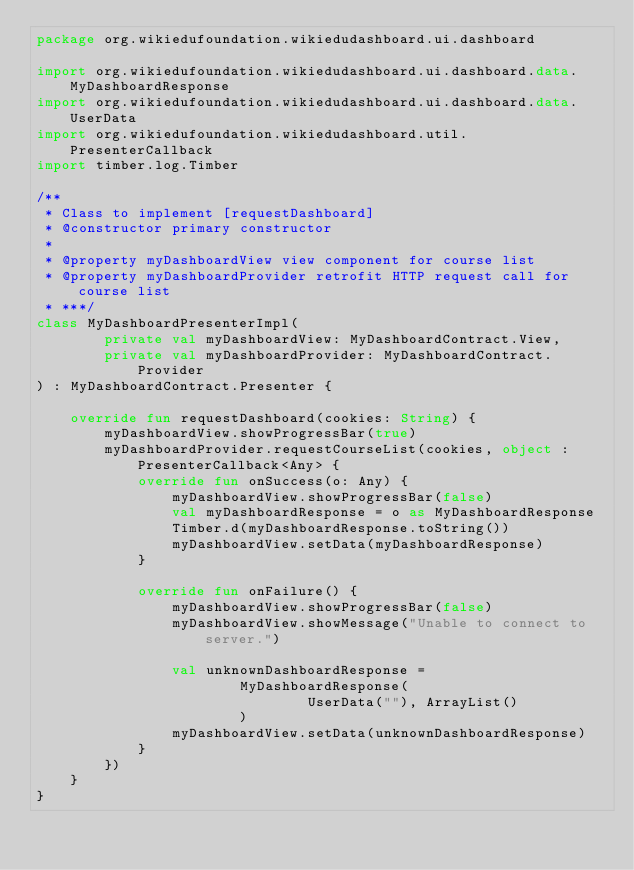Convert code to text. <code><loc_0><loc_0><loc_500><loc_500><_Kotlin_>package org.wikiedufoundation.wikiedudashboard.ui.dashboard

import org.wikiedufoundation.wikiedudashboard.ui.dashboard.data.MyDashboardResponse
import org.wikiedufoundation.wikiedudashboard.ui.dashboard.data.UserData
import org.wikiedufoundation.wikiedudashboard.util.PresenterCallback
import timber.log.Timber

/**
 * Class to implement [requestDashboard]
 * @constructor primary constructor
 *
 * @property myDashboardView view component for course list
 * @property myDashboardProvider retrofit HTTP request call for course list
 * ***/
class MyDashboardPresenterImpl(
        private val myDashboardView: MyDashboardContract.View,
        private val myDashboardProvider: MyDashboardContract.Provider
) : MyDashboardContract.Presenter {

    override fun requestDashboard(cookies: String) {
        myDashboardView.showProgressBar(true)
        myDashboardProvider.requestCourseList(cookies, object : PresenterCallback<Any> {
            override fun onSuccess(o: Any) {
                myDashboardView.showProgressBar(false)
                val myDashboardResponse = o as MyDashboardResponse
                Timber.d(myDashboardResponse.toString())
                myDashboardView.setData(myDashboardResponse)
            }

            override fun onFailure() {
                myDashboardView.showProgressBar(false)
                myDashboardView.showMessage("Unable to connect to server.")

                val unknownDashboardResponse =
                        MyDashboardResponse(
                                UserData(""), ArrayList()
                        )
                myDashboardView.setData(unknownDashboardResponse)
            }
        })
    }
}
</code> 